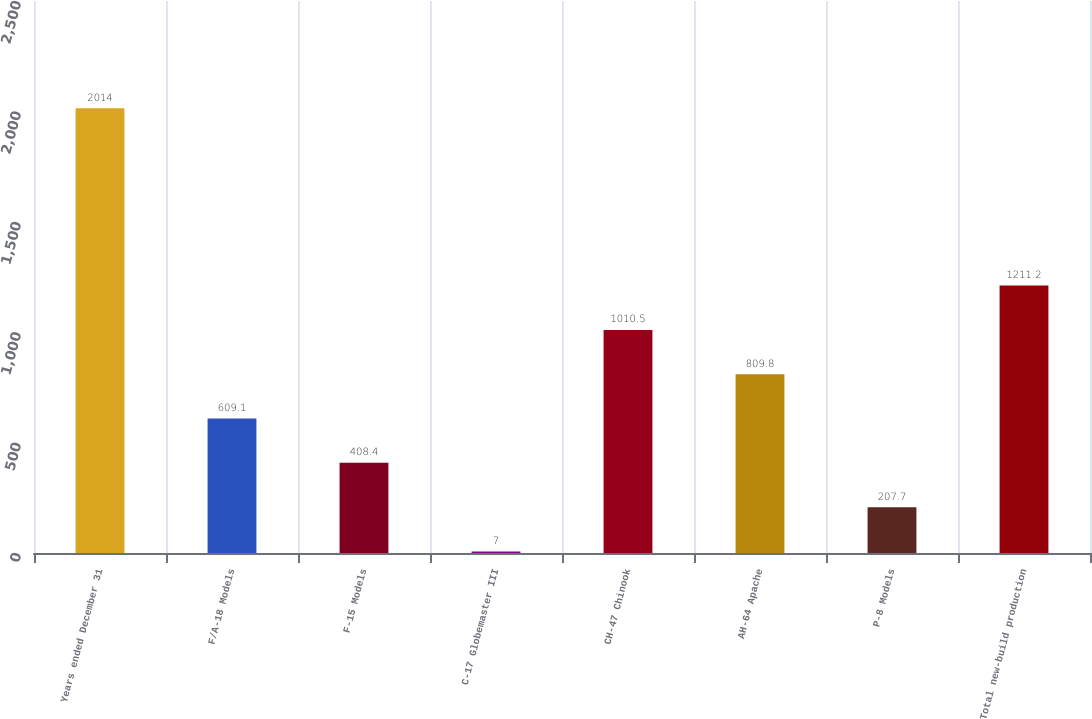<chart> <loc_0><loc_0><loc_500><loc_500><bar_chart><fcel>Years ended December 31<fcel>F/A-18 Models<fcel>F-15 Models<fcel>C-17 Globemaster III<fcel>CH-47 Chinook<fcel>AH-64 Apache<fcel>P-8 Models<fcel>Total new-build production<nl><fcel>2014<fcel>609.1<fcel>408.4<fcel>7<fcel>1010.5<fcel>809.8<fcel>207.7<fcel>1211.2<nl></chart> 